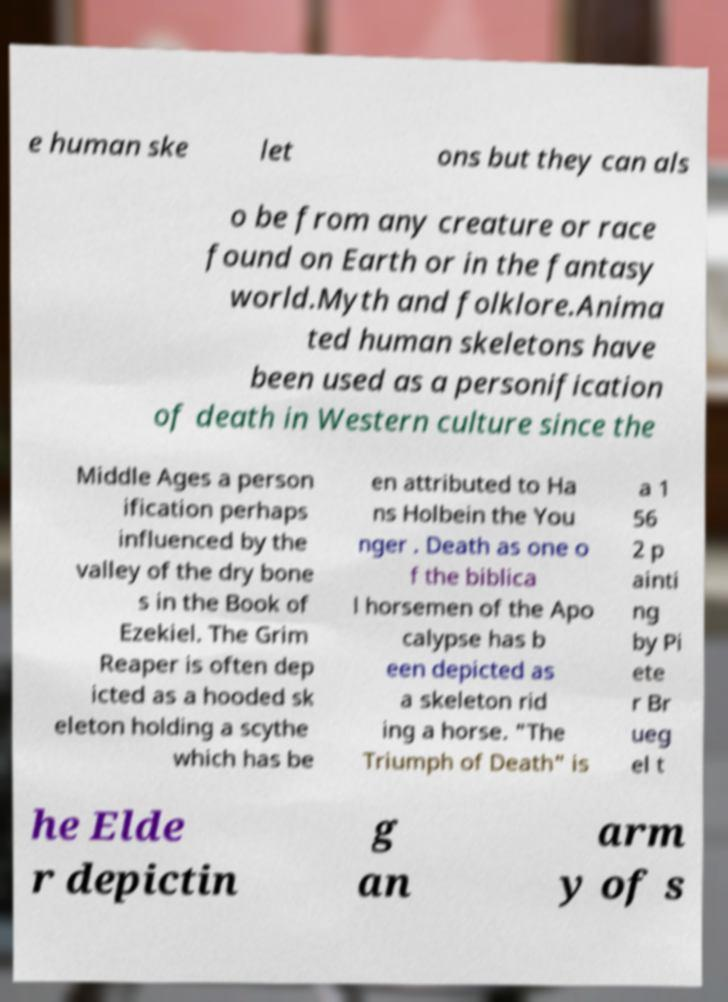Could you assist in decoding the text presented in this image and type it out clearly? e human ske let ons but they can als o be from any creature or race found on Earth or in the fantasy world.Myth and folklore.Anima ted human skeletons have been used as a personification of death in Western culture since the Middle Ages a person ification perhaps influenced by the valley of the dry bone s in the Book of Ezekiel. The Grim Reaper is often dep icted as a hooded sk eleton holding a scythe which has be en attributed to Ha ns Holbein the You nger . Death as one o f the biblica l horsemen of the Apo calypse has b een depicted as a skeleton rid ing a horse. "The Triumph of Death" is a 1 56 2 p ainti ng by Pi ete r Br ueg el t he Elde r depictin g an arm y of s 